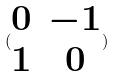Convert formula to latex. <formula><loc_0><loc_0><loc_500><loc_500>( \begin{matrix} 0 & - 1 \\ 1 & 0 \end{matrix} )</formula> 